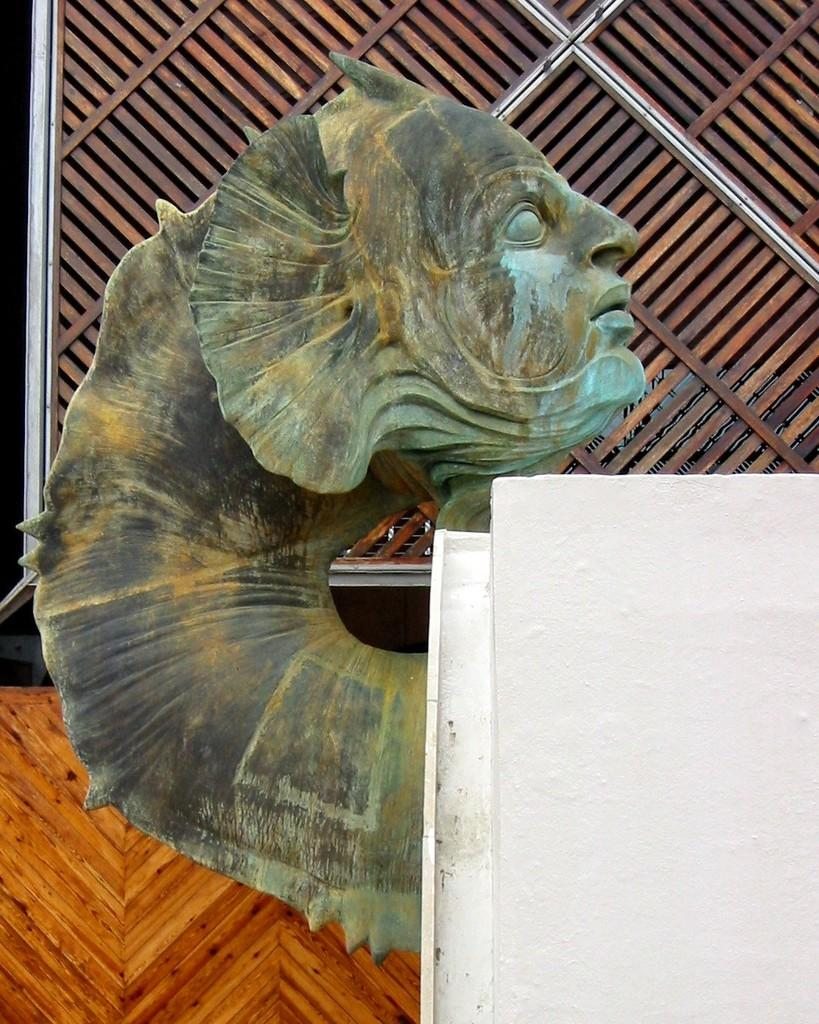What is the main subject in the image? There is a statue in the image. What type of wall is on the right side of the image? There is a white wall on the right side of the image. What can be seen in the background of the image? There is a wooden wall in the background of the image. Can you tell me how many ants are crawling on the statue in the image? There are no ants present on the statue in the image. What type of pet is sitting next to the statue in the image? There is no pet present next to the statue in the image. 